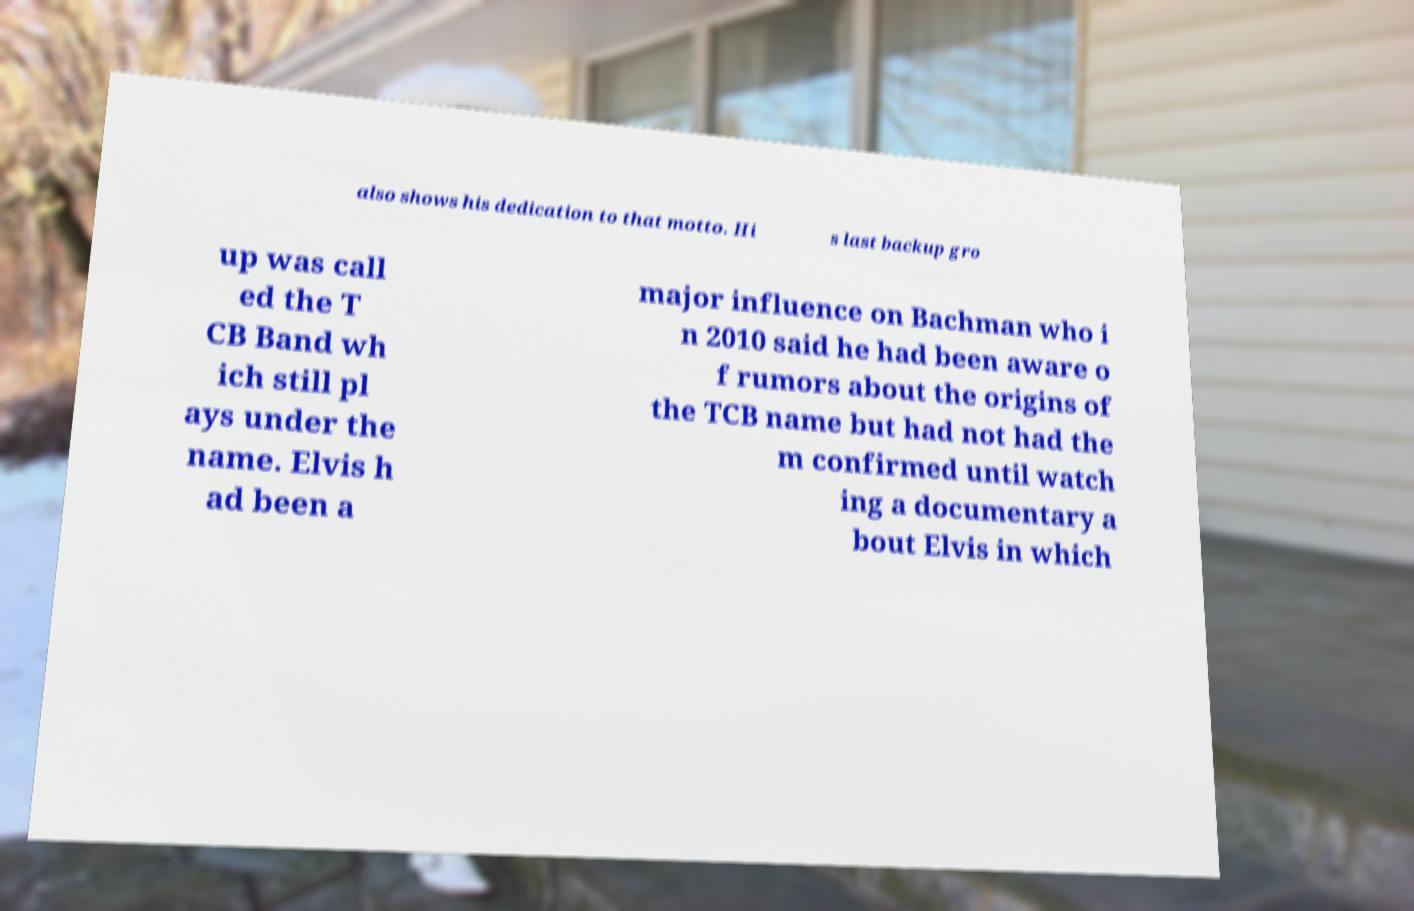There's text embedded in this image that I need extracted. Can you transcribe it verbatim? also shows his dedication to that motto. Hi s last backup gro up was call ed the T CB Band wh ich still pl ays under the name. Elvis h ad been a major influence on Bachman who i n 2010 said he had been aware o f rumors about the origins of the TCB name but had not had the m confirmed until watch ing a documentary a bout Elvis in which 